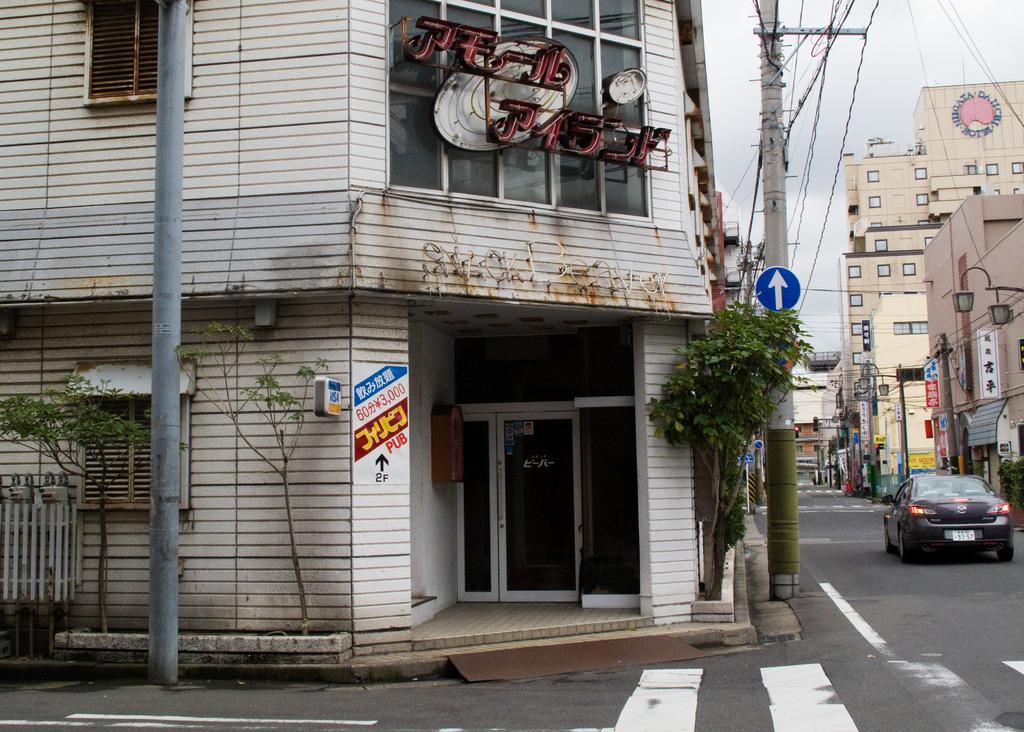Could you give a brief overview of what you see in this image? In this picture we can see few poles, buildings, trees and hoardings, on the right side of the image we can see a car on the road, in the background we can find few lights. 